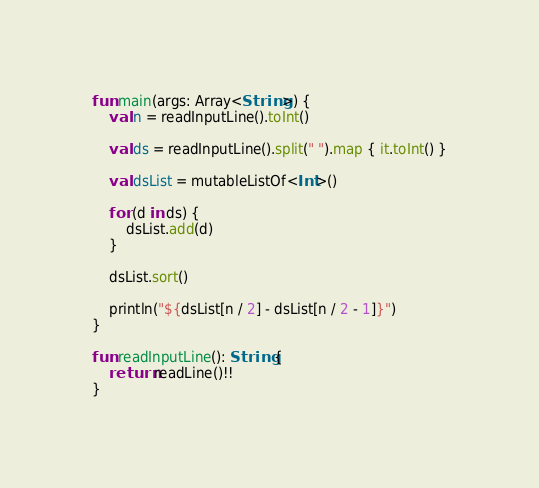<code> <loc_0><loc_0><loc_500><loc_500><_Kotlin_>fun main(args: Array<String>) {
    val n = readInputLine().toInt()
    
    val ds = readInputLine().split(" ").map { it.toInt() }
    
    val dsList = mutableListOf<Int>()
    
    for (d in ds) {
        dsList.add(d)
    }
    
    dsList.sort()
    
    println("${dsList[n / 2] - dsList[n / 2 - 1]}")
}
 
fun readInputLine(): String {
    return readLine()!!
}
</code> 